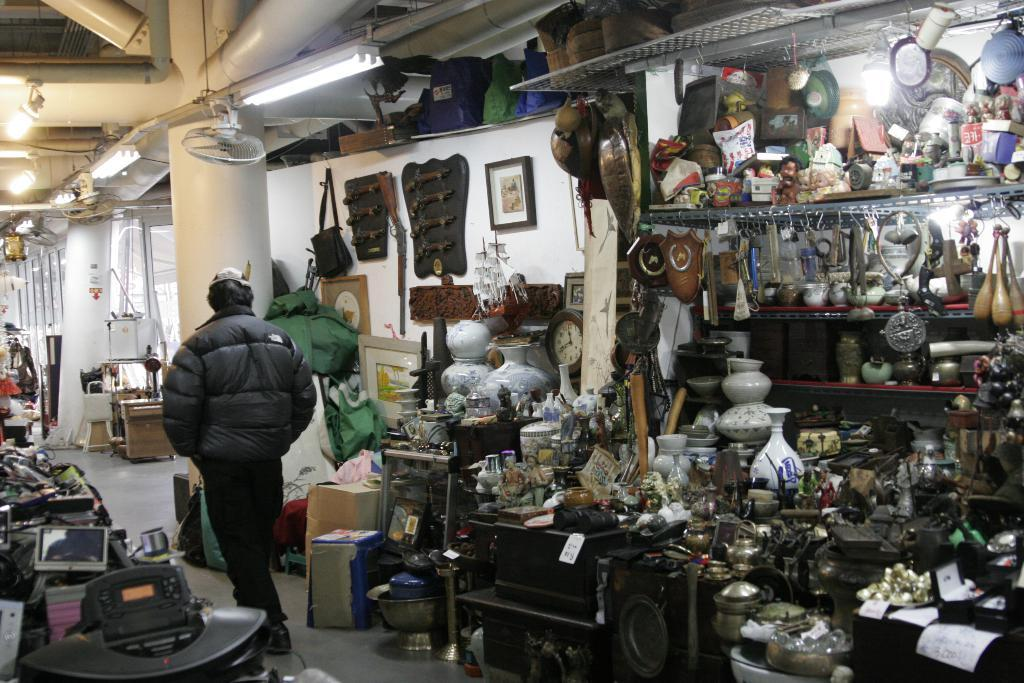What can be seen in the image that supports structures? There are posts in the image that support structures. What is hanging on the wall in the image? There is a photo frame on the wall in the image. What type of objects are visible in the image that can be used for carrying items? There are bags in the image that can be used for carrying items. What is on the floor in the image? There are items on the floor in the image. What provides illumination in the image? There are lights on the ceiling in the image. What type of needle can be seen sewing a stone in the image? There is no needle or stone present in the image. What is the rate of the items falling from the ceiling in the image? There is no indication of items falling from the ceiling in the image, so it is not possible to determine a rate. 